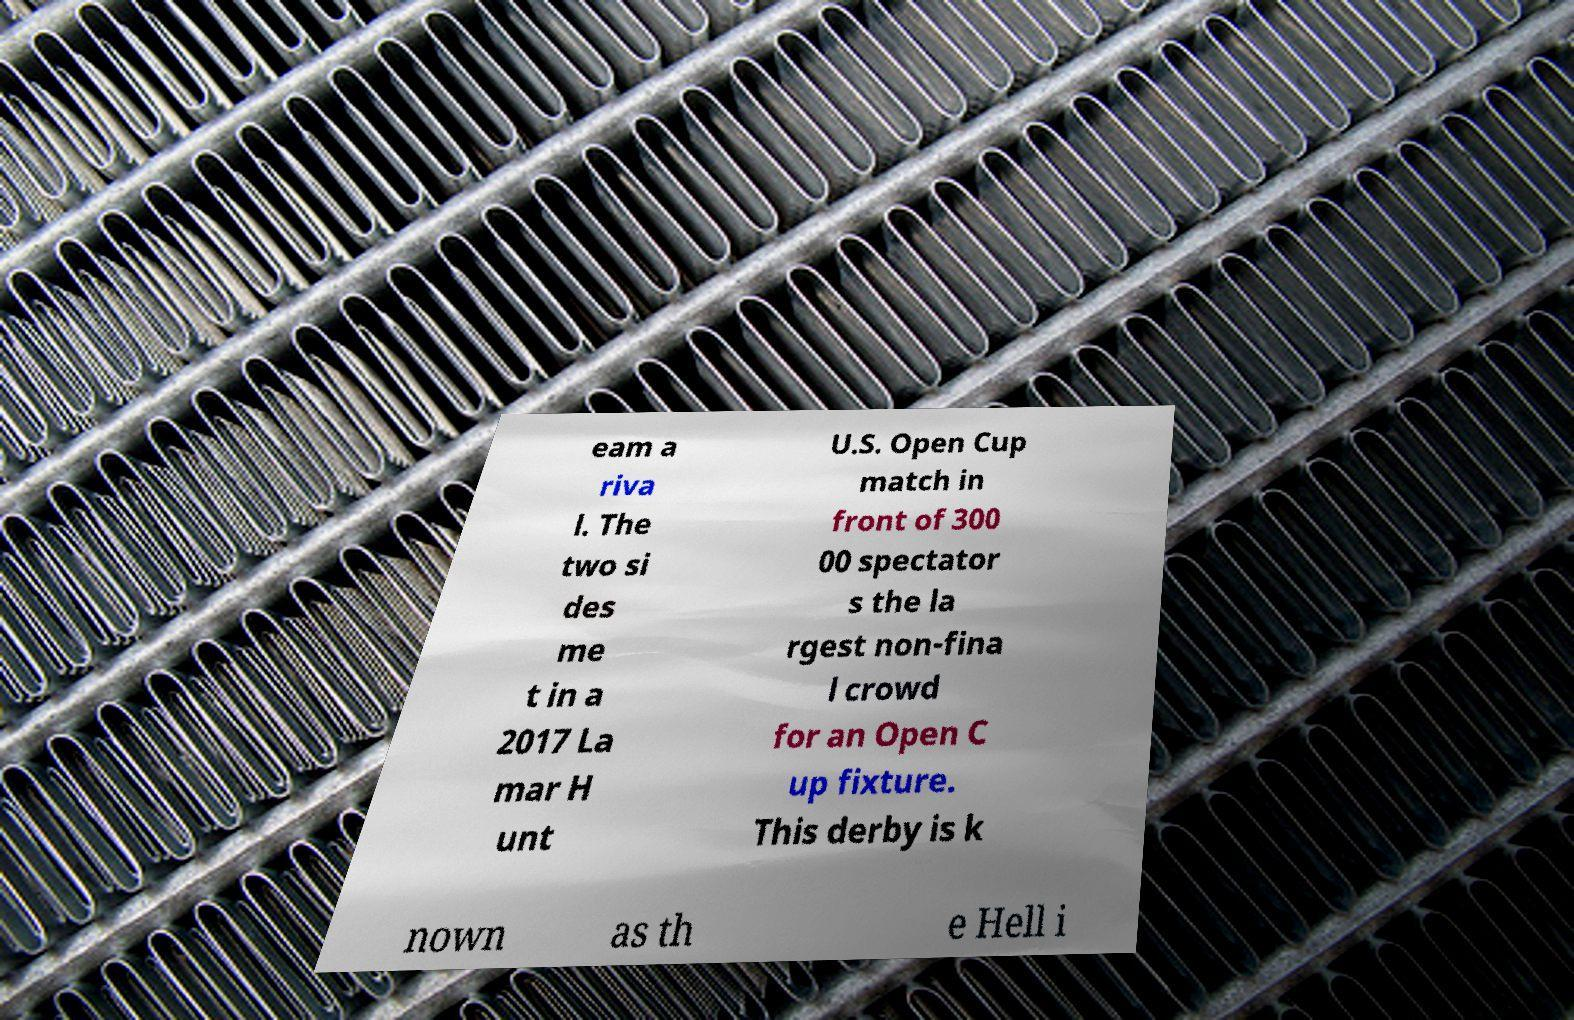Can you accurately transcribe the text from the provided image for me? eam a riva l. The two si des me t in a 2017 La mar H unt U.S. Open Cup match in front of 300 00 spectator s the la rgest non-fina l crowd for an Open C up fixture. This derby is k nown as th e Hell i 